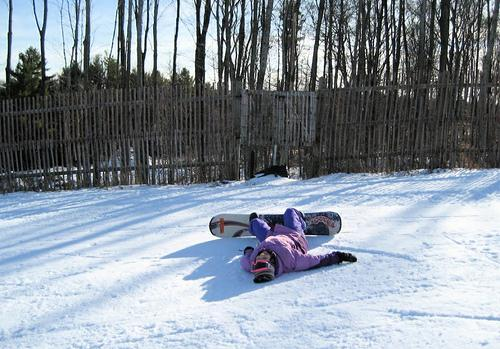Describe the elements in the image as if you were telling someone who has never seen snow before. A girl wearing a snowboard is lying in a soft, cold, and white substance called snow, surrounded by a wooden fence and others enjoying this unique and beautiful environment. Give a poetic description of the image. A serene winter's day unites with a blue sky kissed by white clouds, as a girl adorns the snow like a fallen angel with her snowboard as her wings. Mention the objects and activities found in the image, making a connection to the sky. Beneath the vast blue sky with white clouds, a girl wearing a snowboard lies on a hillside, while people rejoice in the captivating beauty of the snowy outdoors. State the main objects and weather conditions in the image. White clouds in blue sky, white snow on hillside, girl on the ground, wooden stick fence, and people outdoors on a clear day. Describe the scene in the photo with an emphasis on the main character. A girl wearing a snowboard is lying in the white snow with wooden fence next to her and people enjoying the outdoors in the background. Provide a brief summary of the key elements in the image. Female in snow with snowboard, white clouds in blue sky, wooden stick fence, and people enjoying outdoors. Present the atmosphere of the location in the image. A bright and tranquil winter scene with a girl enjoying the snow, white clouds enhancing the blue sky, and people basking in the beauty of the outdoors. List the human-related activities found in the image. Female lying in snow with snowboard, people enjoying the outdoors, girl on the ground, snowboarding, and leisure activities. Mention the prominent colors and objects in the image. Blue sky, white clouds, white snow on hillside, female lying in snow, wooden fence, and people outdoors. In a single sentence, capture the essence of the image. A girl with a snowboard has a moment's rest amidst a beautiful winter landscape, while people savor the splendor of the outdoors. 